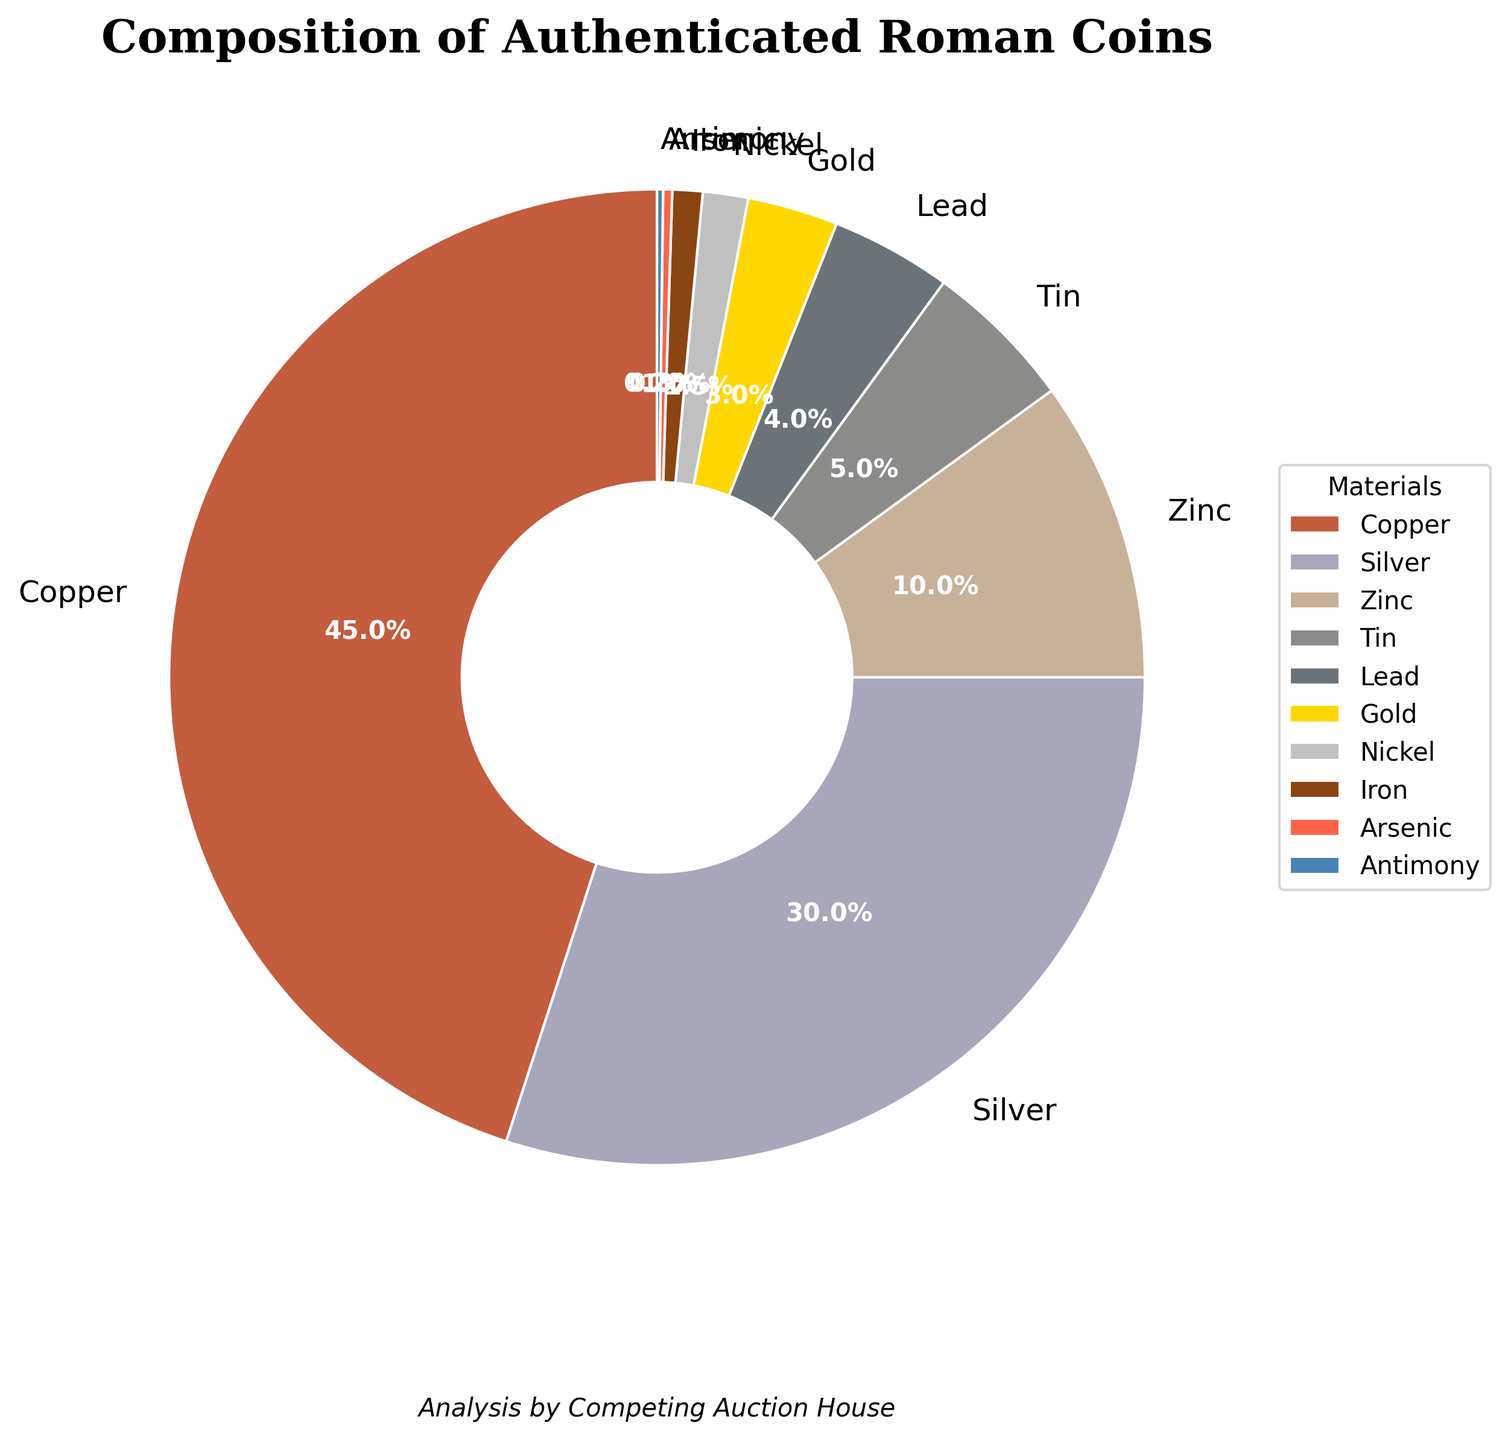What material makes up the majority of the composition in authenticated Roman coins? By examining the pie chart, the segment labeled "Copper" is the largest. Thus, Copper is the majority material in the composition.
Answer: Copper What is the total percentage of materials other than Copper and Silver? Copper accounts for 45% and Silver for 30%. The total percentage is 100%, so subtracting Copper and Silver gives: 100 - (45 + 30) = 25%.
Answer: 25% Which material has a higher percentage, Tin or Zinc? The pie chart shows the percentages for Tin and Zinc as 5% and 10% respectively. Zinc is higher.
Answer: Zinc How does the percentage of Gold compare to Lead? From the pie chart, Gold has a percentage of 3% and Lead has 4%. Thus, Lead is higher than Gold.
Answer: Lead What is the combined percentage of Gold, Nickel, Iron, Arsenic, and Antimony? Adding the percentages from the chart: Gold (3%) + Nickel (1.5%) + Iron (1%) + Arsenic (0.3%) + Antimony (0.2%) results in a total of 6%.
Answer: 6% What materials make up less than 2% of the composition? By inspecting the pie chart, the materials with less than 2% are Nickel (1.5%), Iron (1%), Arsenic (0.3%), and Antimony (0.2%).
Answer: Nickel, Iron, Arsenic, Antimony What is the average percentage of Copper, Silver, and Zinc? Adding the percentages of Copper (45%), Silver (30%), and Zinc (10%) is 45 + 30 + 10 = 85. Dividing by three gives the average: 85 / 3 = 28.33%.
Answer: 28.33% How many materials have a greater percentage than Tin? By examining the chart, Copper (45%), Silver (30%), and Zinc (10%) all have higher percentages than Tin (5%). Thus, there are three materials.
Answer: 3 